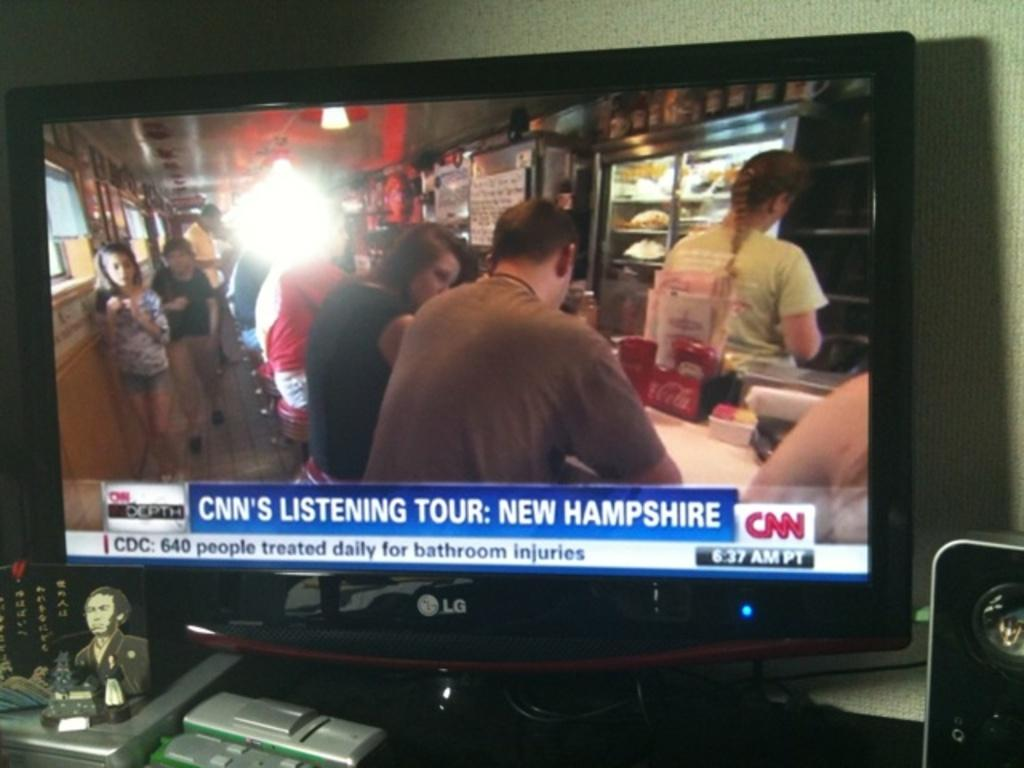<image>
Render a clear and concise summary of the photo. a television that has a CNN show on it 